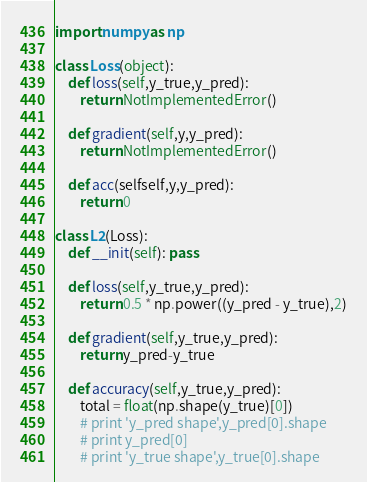Convert code to text. <code><loc_0><loc_0><loc_500><loc_500><_Python_>import numpy as np

class Loss(object):
    def loss(self,y_true,y_pred):
        return NotImplementedError()

    def gradient(self,y,y_pred):
        return NotImplementedError()

    def acc(selfself,y,y_pred):
        return 0

class L2(Loss):
    def __init(self): pass

    def loss(self,y_true,y_pred):
        return 0.5 * np.power((y_pred - y_true),2)

    def gradient(self,y_true,y_pred):
        return y_pred-y_true

    def accuracy(self,y_true,y_pred):
        total = float(np.shape(y_true)[0])
        # print 'y_pred shape',y_pred[0].shape
        # print y_pred[0]
        # print 'y_true shape',y_true[0].shape</code> 